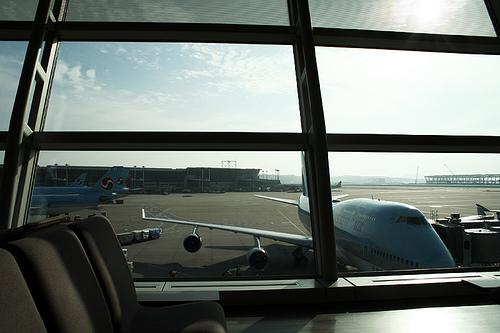Express what you see in the picture using casual slang or informal language. There's a dope airport pic with a sweet blue passenger plane, engines on the wings and all. The sky be cloudy and the sun all bright. The shadows on chairs, wild activities going on, like fog and Pepsi signs on a plane's tail fin. Suppose you're telling a story about this picture. Describe the main event happening here. Once upon a time, at a bustling airport, a blue passenger airplane carrying many smiling passengers was parked by the terminal, its two engines on its wings ready for the next flight, as people admired the various sights, such as a bright sun and an intriguing Pepsi symbol on another plane's tail fin. Describe a scene in a movie set in this location. In this action thriller, our protagonist makes a daring escape from the airport, running past a blue passenger airplane with engines on its wings, narrowly avoiding the obstacles like tables, chairs, and shadows under the bright sun before finally reaching a terminal to make their daring escape. What is in the image's center and what is happening around it? An airport with planes that includes a blue passenger airplane and engines on the wings, a terminal, long overhang, and first-referenced activities such as a cloudy sky, bright sun, shadows on chairs, fog, and a Pepsi symbol on a plane's tail fin. Imagine you are describing the scene to a friend. Briefly summarize what you see. In this image, we see an airport scene with a blue passenger airplane, cloudy sky, bright sun, and engines on the plane's wings. There are shadows on chairs and various activities, such as baggage cars out and lines painted on airport roads. What might someone traveling to this airport observe from the window of the plane? A traveler would see a busy airport with a blue passenger airplane, cloudy sky with a bright sun, engines on the wings of the plane, tables, chairs, various activities including a Pepsi symbol on a tail fin, and buildings around the airport. Pretend you are an art critic describing this image. Please provide your thoughts. This compelling composition explores the juxtaposition of man-made structures like the airport terminal, blue passenger airplane, and baggage cars against natural elements like the cloudy sky and bright sun. The positioning of shadows on chairs and Pepsi symbol on a plane's tail fin adds an element of intrigue and visual appeal to the image. Create a simple advertisement promoting a product related to this image. "Fly in comfort and style with our Blue Sky Airlines - Enjoy clean terminals, punctual flights, and excellent service from our skilled crew. Choose Blue Sky and travel with ease." Write a journal entry from the perspective of an airport worker who has observed this scene. Today, I saw a magnificent blue passenger airplane parked at our airport, its engines resting on its wings. The sun was so bright, casting shadows on chairs and tables despite the cloudy skies. There were a lot of activities going on - baggage cars were out, and I even spotted a Pepsi symbol on another plane's tail fin. It was a busy yet fascinating day at work. What are the most prevalent colors and shapes in this image? In this image, there are prominent colors such as blue, red, gray, and brown associated with the airplane, sky, chairs, and buildings. Shapes in focus include the rectangular and square windows, circular and rectangular chair structures, and engines on the wings. 